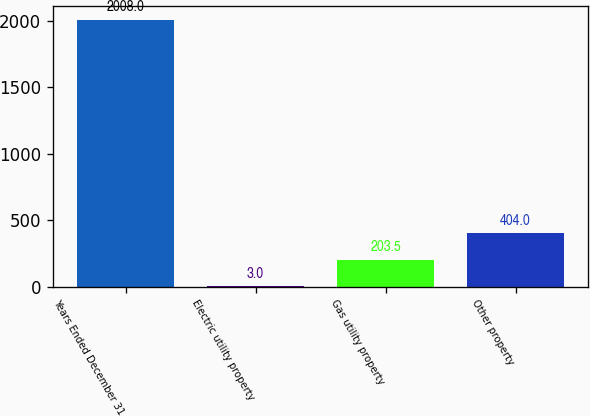Convert chart to OTSL. <chart><loc_0><loc_0><loc_500><loc_500><bar_chart><fcel>Years Ended December 31<fcel>Electric utility property<fcel>Gas utility property<fcel>Other property<nl><fcel>2008<fcel>3<fcel>203.5<fcel>404<nl></chart> 